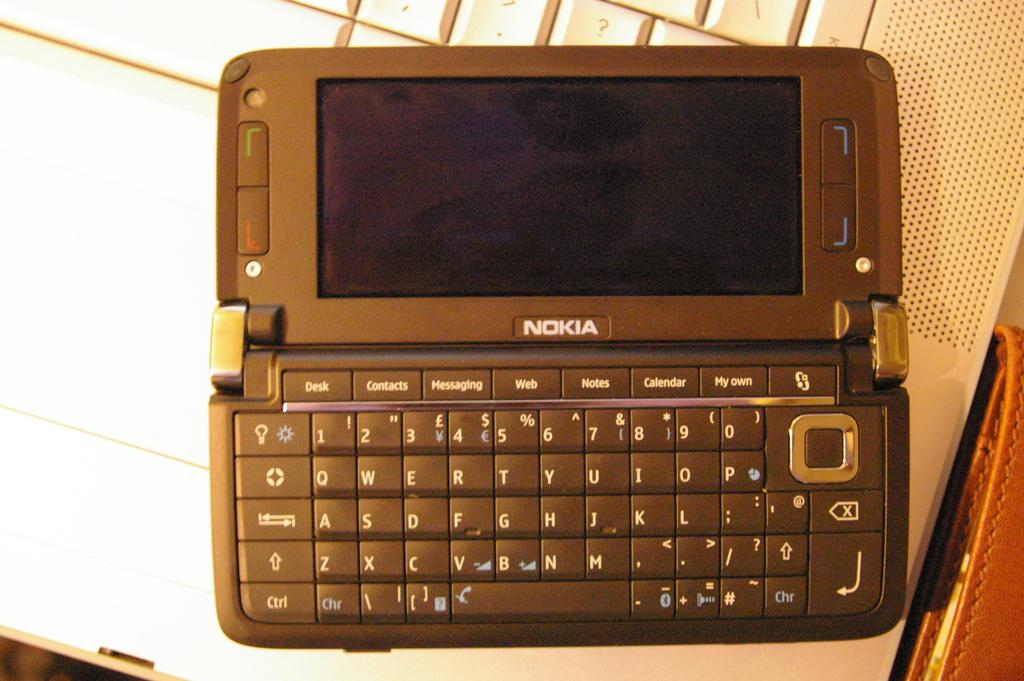<image>
Relay a brief, clear account of the picture shown. Nokia is the brand shown on this personal organizer. 